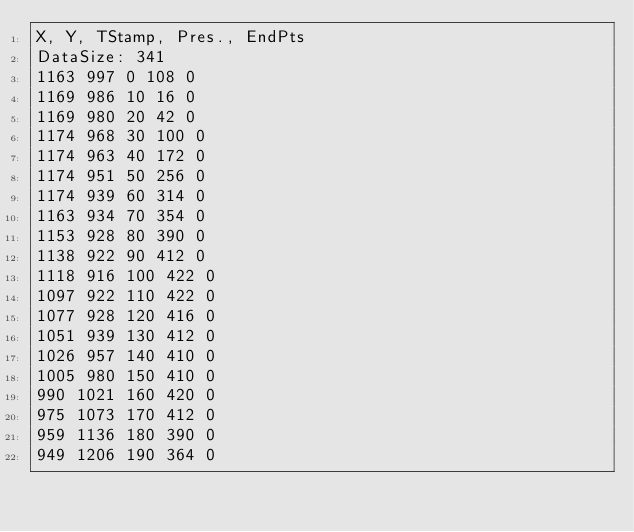Convert code to text. <code><loc_0><loc_0><loc_500><loc_500><_SML_>X, Y, TStamp, Pres., EndPts
DataSize: 341
1163 997 0 108 0
1169 986 10 16 0
1169 980 20 42 0
1174 968 30 100 0
1174 963 40 172 0
1174 951 50 256 0
1174 939 60 314 0
1163 934 70 354 0
1153 928 80 390 0
1138 922 90 412 0
1118 916 100 422 0
1097 922 110 422 0
1077 928 120 416 0
1051 939 130 412 0
1026 957 140 410 0
1005 980 150 410 0
990 1021 160 420 0
975 1073 170 412 0
959 1136 180 390 0
949 1206 190 364 0</code> 